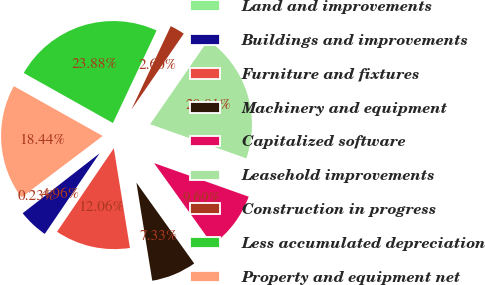<chart> <loc_0><loc_0><loc_500><loc_500><pie_chart><fcel>Land and improvements<fcel>Buildings and improvements<fcel>Furniture and fixtures<fcel>Machinery and equipment<fcel>Capitalized software<fcel>Leasehold improvements<fcel>Construction in progress<fcel>Less accumulated depreciation<fcel>Property and equipment net<nl><fcel>0.23%<fcel>4.96%<fcel>12.06%<fcel>7.33%<fcel>9.69%<fcel>20.81%<fcel>2.6%<fcel>23.88%<fcel>18.44%<nl></chart> 